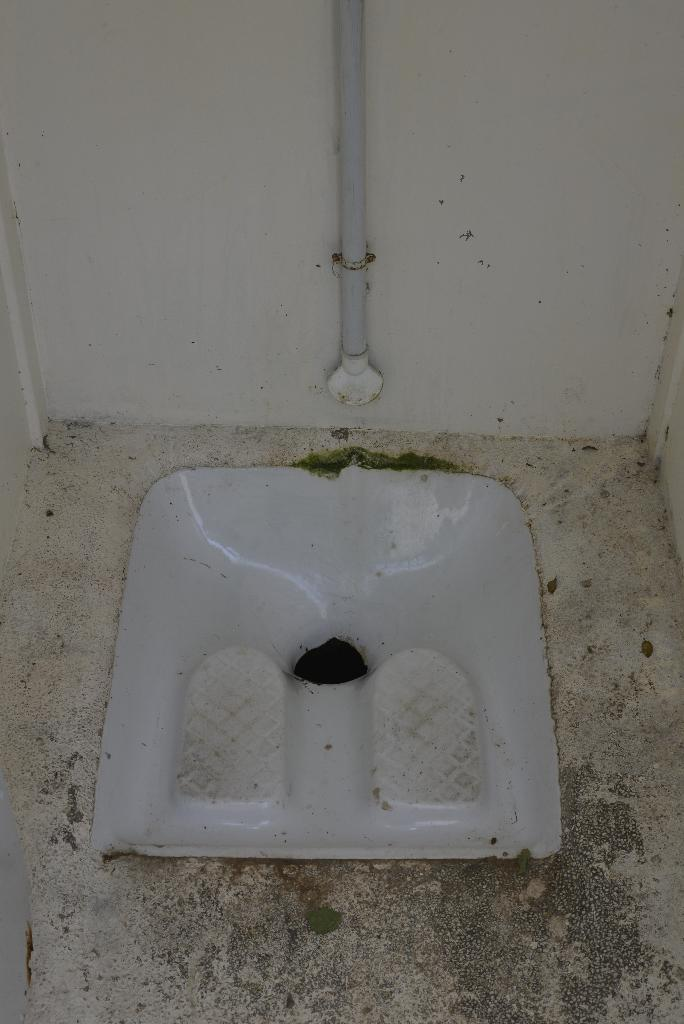What type of room is shown in the image? The image depicts a washroom. What can be found in a typical washroom that is visible in the image? There is a toilet seat in the image. What is visible in the background of the image? There is a wall in the background of the image. What is attached to the wall in the image? There is a pole attached to the wall in the image. What type of breakfast is being served on the pole in the image? There is no breakfast or food present in the image; the pole is attached to the wall in a washroom. 